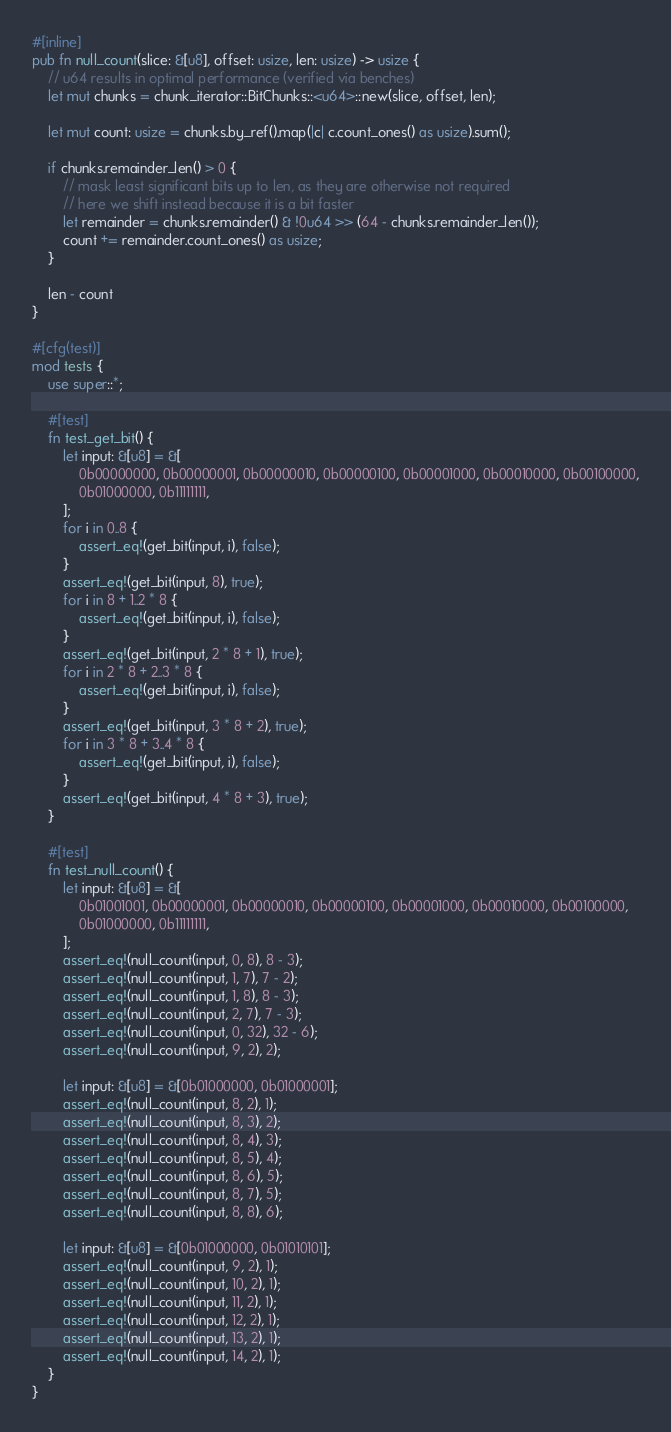<code> <loc_0><loc_0><loc_500><loc_500><_Rust_>
#[inline]
pub fn null_count(slice: &[u8], offset: usize, len: usize) -> usize {
    // u64 results in optimal performance (verified via benches)
    let mut chunks = chunk_iterator::BitChunks::<u64>::new(slice, offset, len);

    let mut count: usize = chunks.by_ref().map(|c| c.count_ones() as usize).sum();

    if chunks.remainder_len() > 0 {
        // mask least significant bits up to len, as they are otherwise not required
        // here we shift instead because it is a bit faster
        let remainder = chunks.remainder() & !0u64 >> (64 - chunks.remainder_len());
        count += remainder.count_ones() as usize;
    }

    len - count
}

#[cfg(test)]
mod tests {
    use super::*;

    #[test]
    fn test_get_bit() {
        let input: &[u8] = &[
            0b00000000, 0b00000001, 0b00000010, 0b00000100, 0b00001000, 0b00010000, 0b00100000,
            0b01000000, 0b11111111,
        ];
        for i in 0..8 {
            assert_eq!(get_bit(input, i), false);
        }
        assert_eq!(get_bit(input, 8), true);
        for i in 8 + 1..2 * 8 {
            assert_eq!(get_bit(input, i), false);
        }
        assert_eq!(get_bit(input, 2 * 8 + 1), true);
        for i in 2 * 8 + 2..3 * 8 {
            assert_eq!(get_bit(input, i), false);
        }
        assert_eq!(get_bit(input, 3 * 8 + 2), true);
        for i in 3 * 8 + 3..4 * 8 {
            assert_eq!(get_bit(input, i), false);
        }
        assert_eq!(get_bit(input, 4 * 8 + 3), true);
    }

    #[test]
    fn test_null_count() {
        let input: &[u8] = &[
            0b01001001, 0b00000001, 0b00000010, 0b00000100, 0b00001000, 0b00010000, 0b00100000,
            0b01000000, 0b11111111,
        ];
        assert_eq!(null_count(input, 0, 8), 8 - 3);
        assert_eq!(null_count(input, 1, 7), 7 - 2);
        assert_eq!(null_count(input, 1, 8), 8 - 3);
        assert_eq!(null_count(input, 2, 7), 7 - 3);
        assert_eq!(null_count(input, 0, 32), 32 - 6);
        assert_eq!(null_count(input, 9, 2), 2);

        let input: &[u8] = &[0b01000000, 0b01000001];
        assert_eq!(null_count(input, 8, 2), 1);
        assert_eq!(null_count(input, 8, 3), 2);
        assert_eq!(null_count(input, 8, 4), 3);
        assert_eq!(null_count(input, 8, 5), 4);
        assert_eq!(null_count(input, 8, 6), 5);
        assert_eq!(null_count(input, 8, 7), 5);
        assert_eq!(null_count(input, 8, 8), 6);

        let input: &[u8] = &[0b01000000, 0b01010101];
        assert_eq!(null_count(input, 9, 2), 1);
        assert_eq!(null_count(input, 10, 2), 1);
        assert_eq!(null_count(input, 11, 2), 1);
        assert_eq!(null_count(input, 12, 2), 1);
        assert_eq!(null_count(input, 13, 2), 1);
        assert_eq!(null_count(input, 14, 2), 1);
    }
}
</code> 